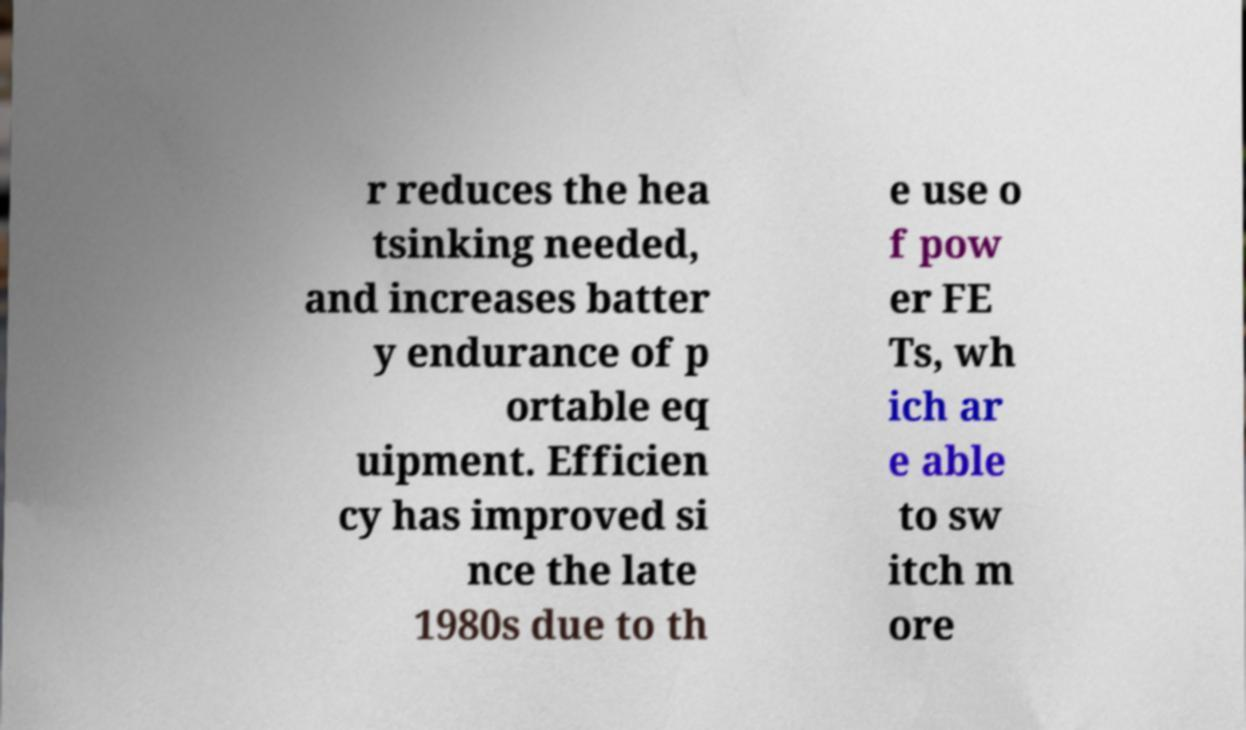Please identify and transcribe the text found in this image. r reduces the hea tsinking needed, and increases batter y endurance of p ortable eq uipment. Efficien cy has improved si nce the late 1980s due to th e use o f pow er FE Ts, wh ich ar e able to sw itch m ore 